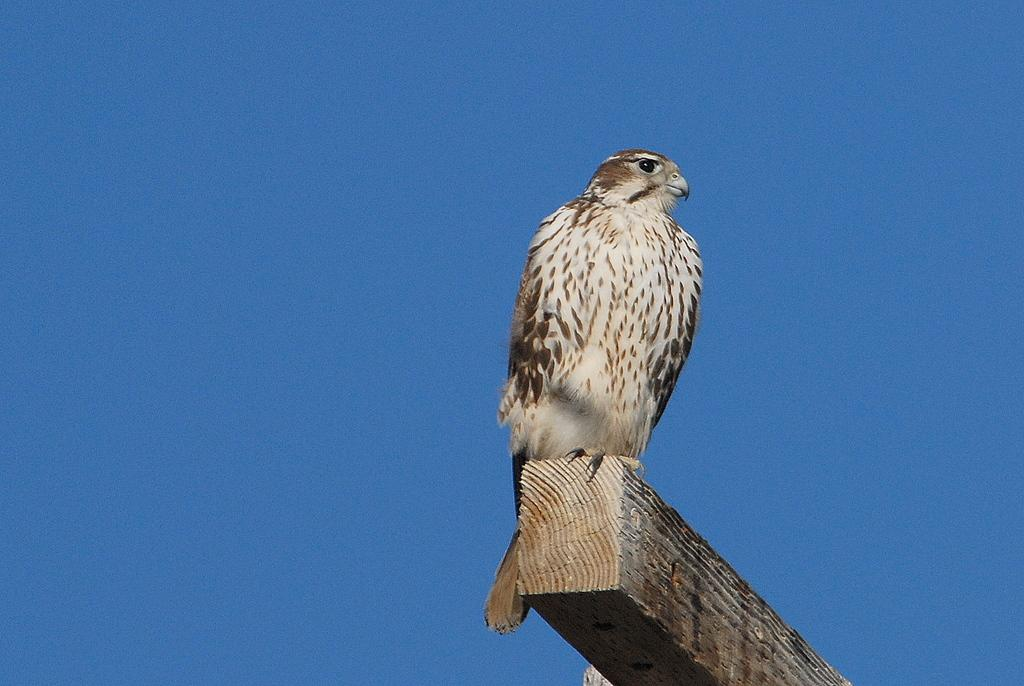What animal is featured in the image? There is an eagle in the image. What is the eagle standing on? The eagle is on a wooden plank. What can be seen in the background of the image? The sky is visible in the background of the image. What type of appliance is the eagle using in the image? There is no appliance present in the image; the eagle is simply standing on a wooden plank. How many feet can be seen in the image? The image only features an eagle, and eagles have two feet, but they are not visible in the image. 